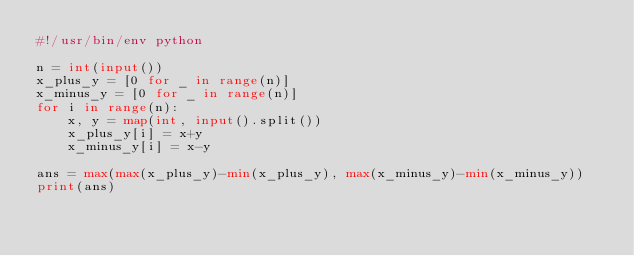<code> <loc_0><loc_0><loc_500><loc_500><_Python_>#!/usr/bin/env python

n = int(input())
x_plus_y = [0 for _ in range(n)]
x_minus_y = [0 for _ in range(n)]
for i in range(n):
    x, y = map(int, input().split())
    x_plus_y[i] = x+y 
    x_minus_y[i] = x-y 

ans = max(max(x_plus_y)-min(x_plus_y), max(x_minus_y)-min(x_minus_y))
print(ans)
</code> 